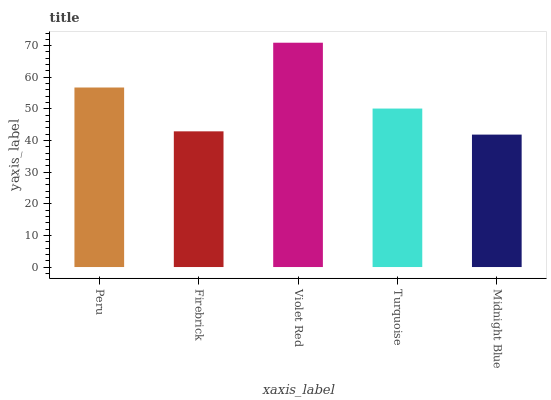Is Midnight Blue the minimum?
Answer yes or no. Yes. Is Violet Red the maximum?
Answer yes or no. Yes. Is Firebrick the minimum?
Answer yes or no. No. Is Firebrick the maximum?
Answer yes or no. No. Is Peru greater than Firebrick?
Answer yes or no. Yes. Is Firebrick less than Peru?
Answer yes or no. Yes. Is Firebrick greater than Peru?
Answer yes or no. No. Is Peru less than Firebrick?
Answer yes or no. No. Is Turquoise the high median?
Answer yes or no. Yes. Is Turquoise the low median?
Answer yes or no. Yes. Is Violet Red the high median?
Answer yes or no. No. Is Violet Red the low median?
Answer yes or no. No. 